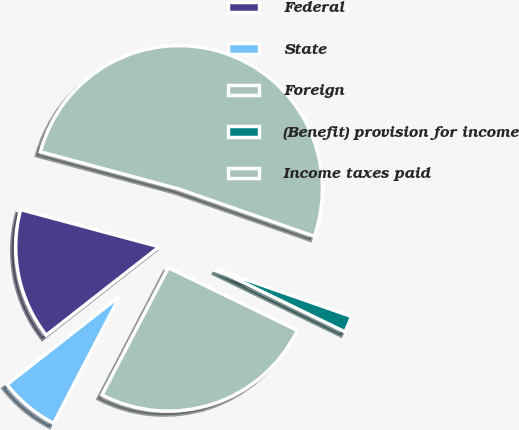Convert chart to OTSL. <chart><loc_0><loc_0><loc_500><loc_500><pie_chart><fcel>Federal<fcel>State<fcel>Foreign<fcel>(Benefit) provision for income<fcel>Income taxes paid<nl><fcel>14.75%<fcel>6.78%<fcel>25.45%<fcel>1.85%<fcel>51.17%<nl></chart> 